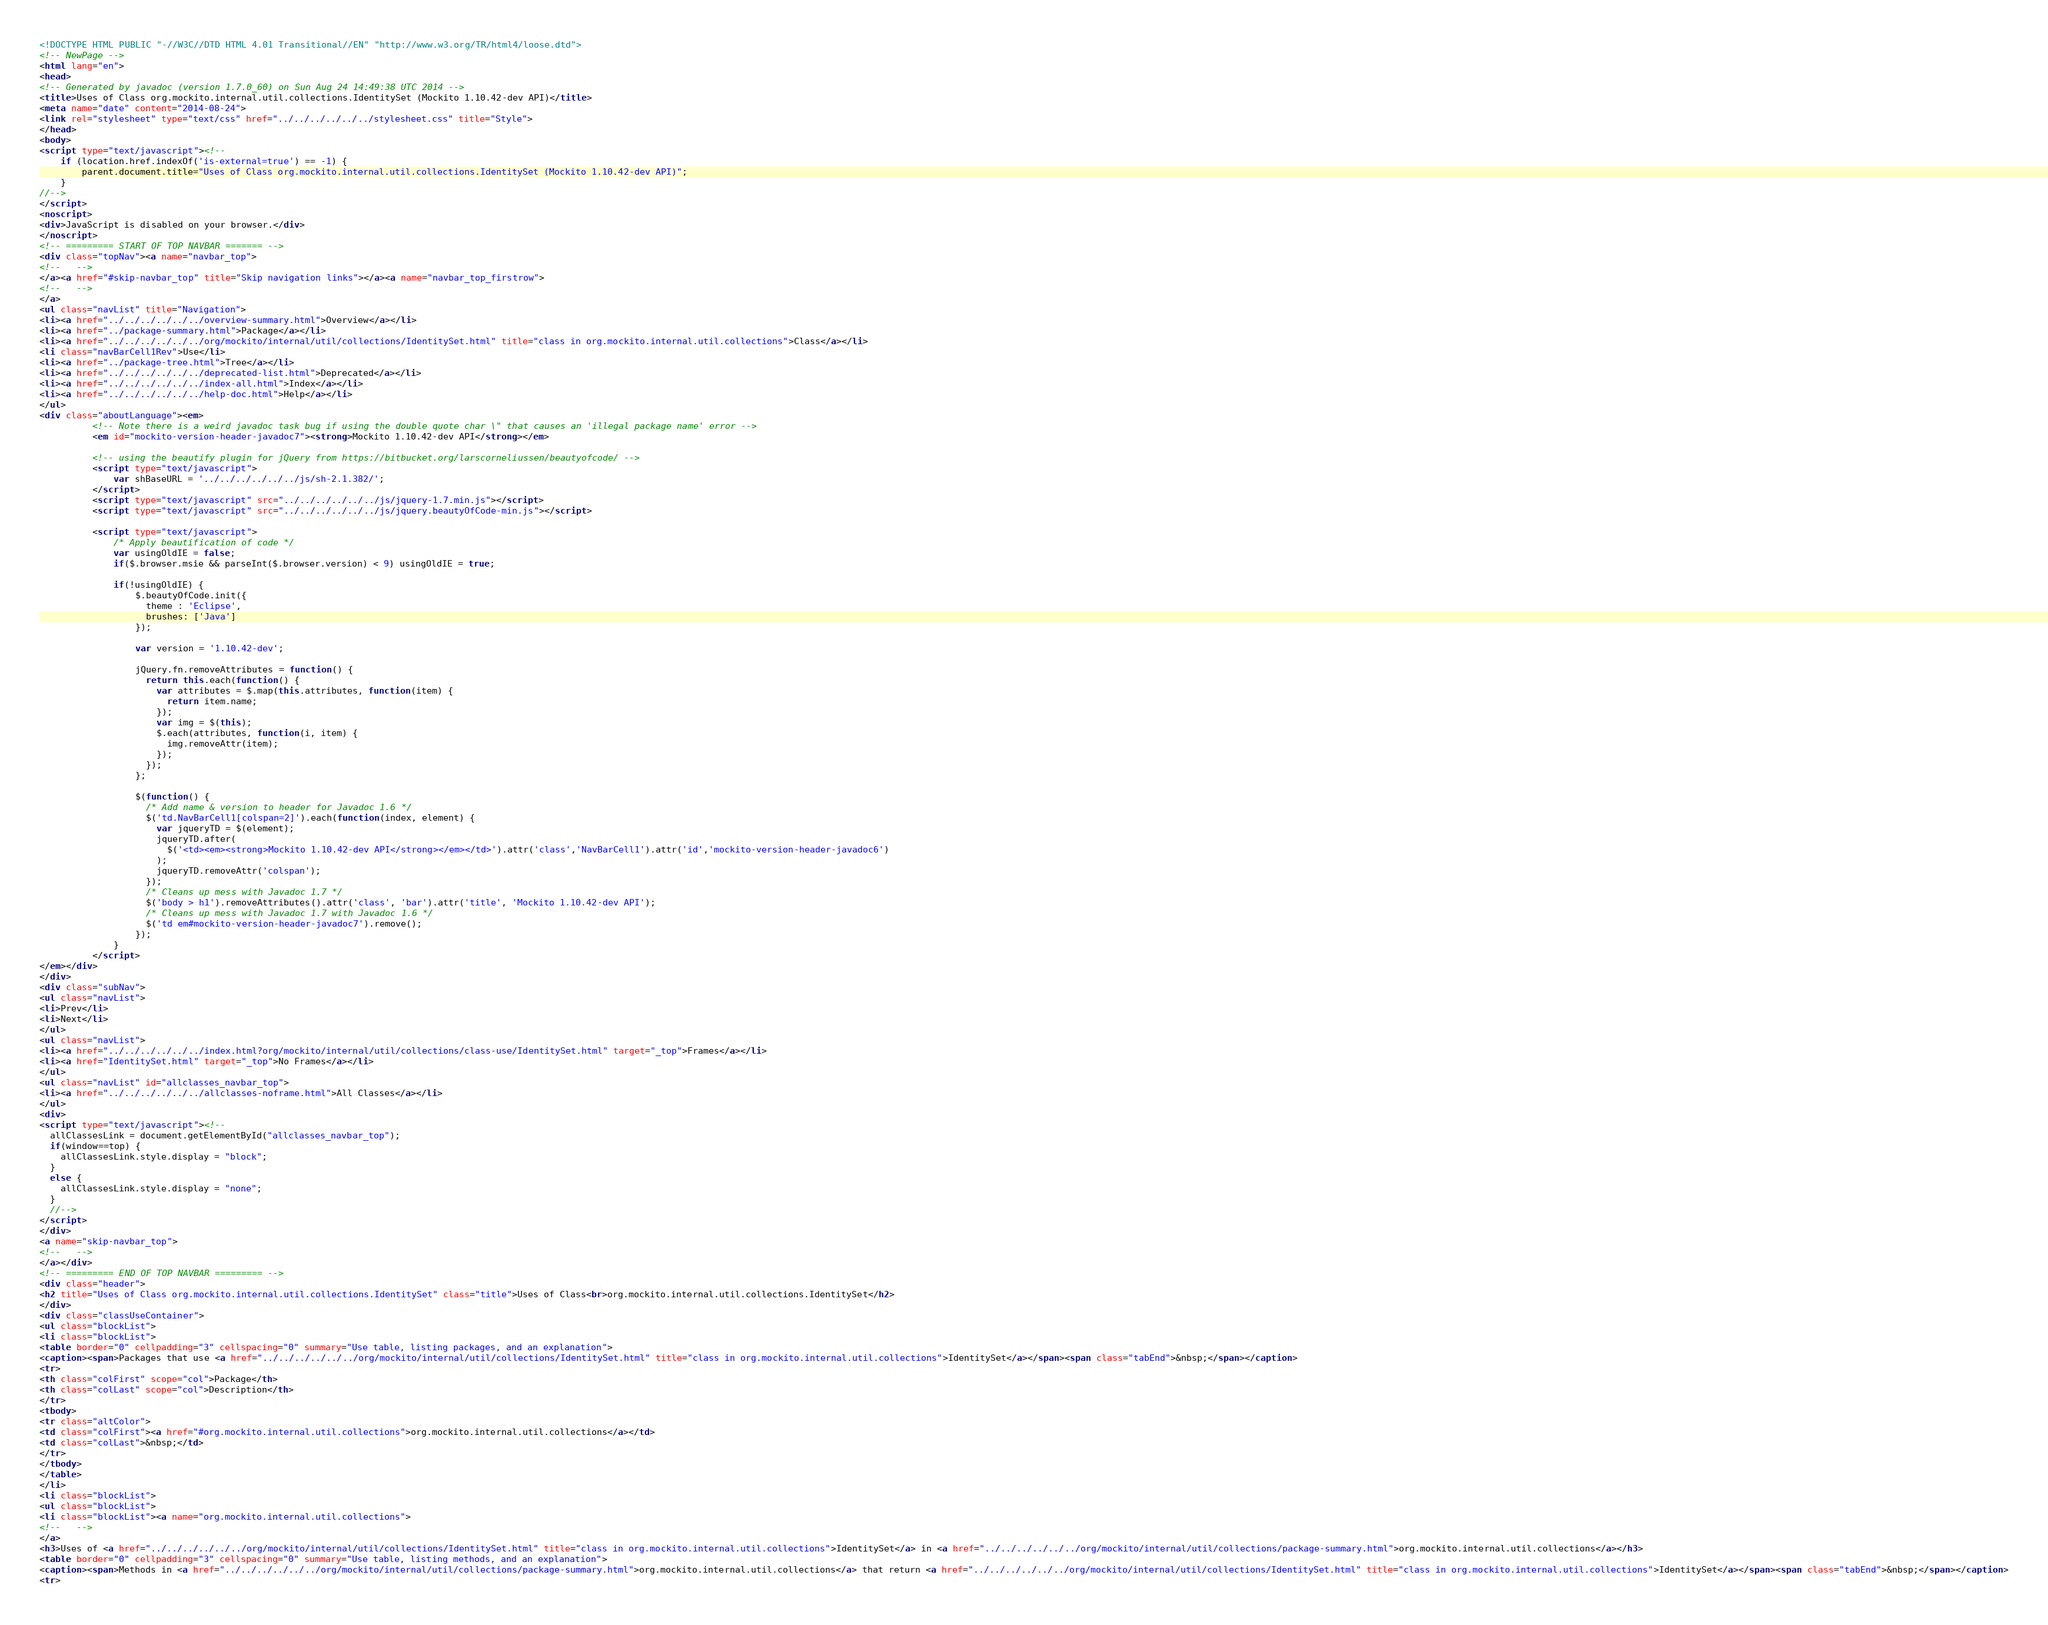Convert code to text. <code><loc_0><loc_0><loc_500><loc_500><_HTML_><!DOCTYPE HTML PUBLIC "-//W3C//DTD HTML 4.01 Transitional//EN" "http://www.w3.org/TR/html4/loose.dtd">
<!-- NewPage -->
<html lang="en">
<head>
<!-- Generated by javadoc (version 1.7.0_60) on Sun Aug 24 14:49:38 UTC 2014 -->
<title>Uses of Class org.mockito.internal.util.collections.IdentitySet (Mockito 1.10.42-dev API)</title>
<meta name="date" content="2014-08-24">
<link rel="stylesheet" type="text/css" href="../../../../../../stylesheet.css" title="Style">
</head>
<body>
<script type="text/javascript"><!--
    if (location.href.indexOf('is-external=true') == -1) {
        parent.document.title="Uses of Class org.mockito.internal.util.collections.IdentitySet (Mockito 1.10.42-dev API)";
    }
//-->
</script>
<noscript>
<div>JavaScript is disabled on your browser.</div>
</noscript>
<!-- ========= START OF TOP NAVBAR ======= -->
<div class="topNav"><a name="navbar_top">
<!--   -->
</a><a href="#skip-navbar_top" title="Skip navigation links"></a><a name="navbar_top_firstrow">
<!--   -->
</a>
<ul class="navList" title="Navigation">
<li><a href="../../../../../../overview-summary.html">Overview</a></li>
<li><a href="../package-summary.html">Package</a></li>
<li><a href="../../../../../../org/mockito/internal/util/collections/IdentitySet.html" title="class in org.mockito.internal.util.collections">Class</a></li>
<li class="navBarCell1Rev">Use</li>
<li><a href="../package-tree.html">Tree</a></li>
<li><a href="../../../../../../deprecated-list.html">Deprecated</a></li>
<li><a href="../../../../../../index-all.html">Index</a></li>
<li><a href="../../../../../../help-doc.html">Help</a></li>
</ul>
<div class="aboutLanguage"><em>
          <!-- Note there is a weird javadoc task bug if using the double quote char \" that causes an 'illegal package name' error -->
          <em id="mockito-version-header-javadoc7"><strong>Mockito 1.10.42-dev API</strong></em>

          <!-- using the beautify plugin for jQuery from https://bitbucket.org/larscorneliussen/beautyofcode/ -->
          <script type="text/javascript">
              var shBaseURL = '../../../../../../js/sh-2.1.382/';
          </script>
          <script type="text/javascript" src="../../../../../../js/jquery-1.7.min.js"></script>
          <script type="text/javascript" src="../../../../../../js/jquery.beautyOfCode-min.js"></script>

          <script type="text/javascript">
              /* Apply beautification of code */
              var usingOldIE = false;
              if($.browser.msie && parseInt($.browser.version) < 9) usingOldIE = true;

              if(!usingOldIE) {
                  $.beautyOfCode.init({
                    theme : 'Eclipse',
                    brushes: ['Java']
                  });

                  var version = '1.10.42-dev';

                  jQuery.fn.removeAttributes = function() {
                    return this.each(function() {
                      var attributes = $.map(this.attributes, function(item) {
                        return item.name;
                      });
                      var img = $(this);
                      $.each(attributes, function(i, item) {
                        img.removeAttr(item);
                      });
                    });
                  };

                  $(function() {
                    /* Add name & version to header for Javadoc 1.6 */
                    $('td.NavBarCell1[colspan=2]').each(function(index, element) {
                      var jqueryTD = $(element);
                      jqueryTD.after(
                        $('<td><em><strong>Mockito 1.10.42-dev API</strong></em></td>').attr('class','NavBarCell1').attr('id','mockito-version-header-javadoc6')
                      );
                      jqueryTD.removeAttr('colspan');
                    });
                    /* Cleans up mess with Javadoc 1.7 */
                    $('body > h1').removeAttributes().attr('class', 'bar').attr('title', 'Mockito 1.10.42-dev API');
                    /* Cleans up mess with Javadoc 1.7 with Javadoc 1.6 */
                    $('td em#mockito-version-header-javadoc7').remove();
                  });
              }
          </script>
</em></div>
</div>
<div class="subNav">
<ul class="navList">
<li>Prev</li>
<li>Next</li>
</ul>
<ul class="navList">
<li><a href="../../../../../../index.html?org/mockito/internal/util/collections/class-use/IdentitySet.html" target="_top">Frames</a></li>
<li><a href="IdentitySet.html" target="_top">No Frames</a></li>
</ul>
<ul class="navList" id="allclasses_navbar_top">
<li><a href="../../../../../../allclasses-noframe.html">All Classes</a></li>
</ul>
<div>
<script type="text/javascript"><!--
  allClassesLink = document.getElementById("allclasses_navbar_top");
  if(window==top) {
    allClassesLink.style.display = "block";
  }
  else {
    allClassesLink.style.display = "none";
  }
  //-->
</script>
</div>
<a name="skip-navbar_top">
<!--   -->
</a></div>
<!-- ========= END OF TOP NAVBAR ========= -->
<div class="header">
<h2 title="Uses of Class org.mockito.internal.util.collections.IdentitySet" class="title">Uses of Class<br>org.mockito.internal.util.collections.IdentitySet</h2>
</div>
<div class="classUseContainer">
<ul class="blockList">
<li class="blockList">
<table border="0" cellpadding="3" cellspacing="0" summary="Use table, listing packages, and an explanation">
<caption><span>Packages that use <a href="../../../../../../org/mockito/internal/util/collections/IdentitySet.html" title="class in org.mockito.internal.util.collections">IdentitySet</a></span><span class="tabEnd">&nbsp;</span></caption>
<tr>
<th class="colFirst" scope="col">Package</th>
<th class="colLast" scope="col">Description</th>
</tr>
<tbody>
<tr class="altColor">
<td class="colFirst"><a href="#org.mockito.internal.util.collections">org.mockito.internal.util.collections</a></td>
<td class="colLast">&nbsp;</td>
</tr>
</tbody>
</table>
</li>
<li class="blockList">
<ul class="blockList">
<li class="blockList"><a name="org.mockito.internal.util.collections">
<!--   -->
</a>
<h3>Uses of <a href="../../../../../../org/mockito/internal/util/collections/IdentitySet.html" title="class in org.mockito.internal.util.collections">IdentitySet</a> in <a href="../../../../../../org/mockito/internal/util/collections/package-summary.html">org.mockito.internal.util.collections</a></h3>
<table border="0" cellpadding="3" cellspacing="0" summary="Use table, listing methods, and an explanation">
<caption><span>Methods in <a href="../../../../../../org/mockito/internal/util/collections/package-summary.html">org.mockito.internal.util.collections</a> that return <a href="../../../../../../org/mockito/internal/util/collections/IdentitySet.html" title="class in org.mockito.internal.util.collections">IdentitySet</a></span><span class="tabEnd">&nbsp;</span></caption>
<tr></code> 